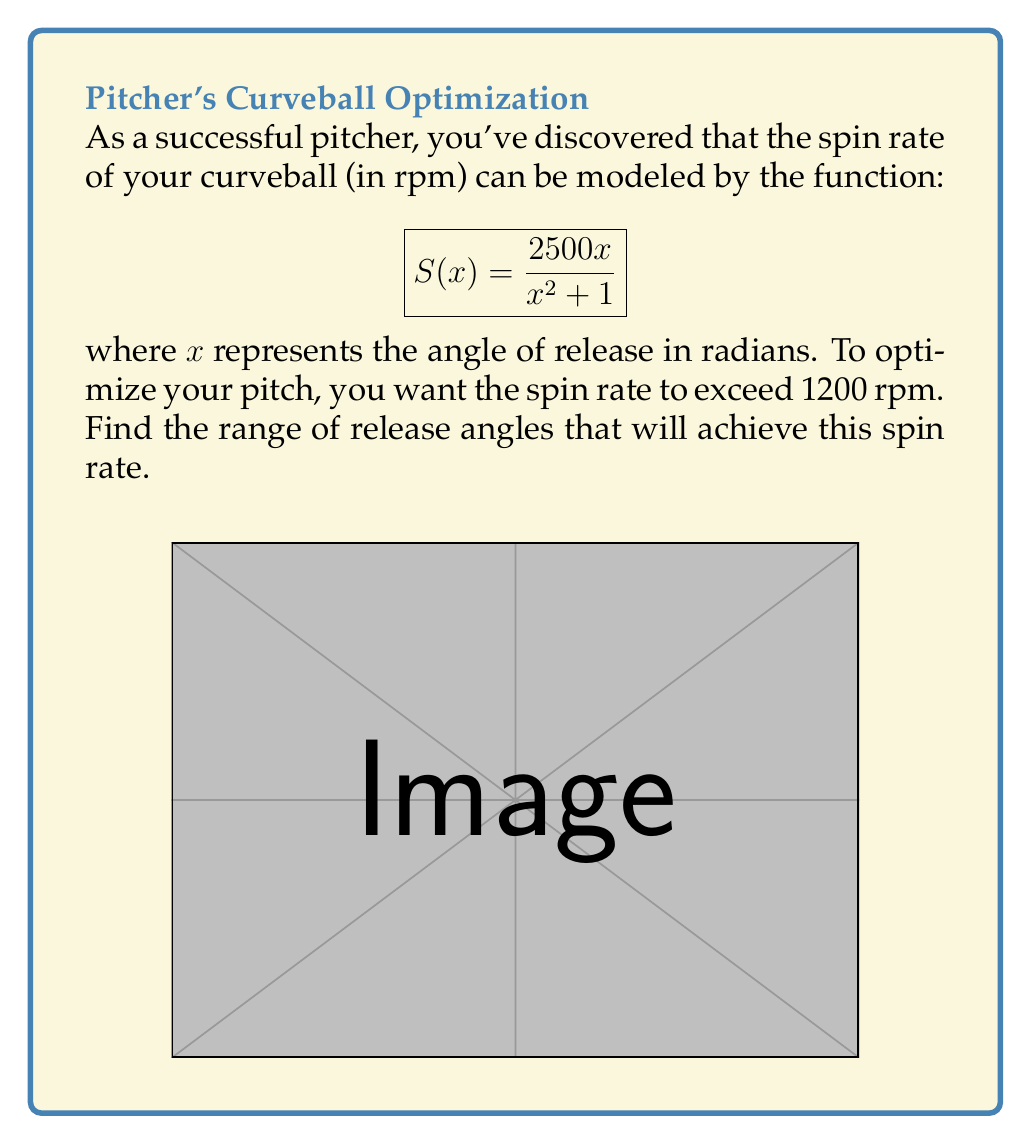Solve this math problem. Let's approach this step-by-step:

1) We want to find $x$ values where $S(x) > 1200$. This gives us the inequality:

   $$\frac{2500x}{x^2 + 1} > 1200$$

2) Multiply both sides by $(x^2 + 1)$ (which is always positive):

   $$2500x > 1200(x^2 + 1)$$

3) Expand the right side:

   $$2500x > 1200x^2 + 1200$$

4) Subtract 2500x from both sides:

   $$0 > 1200x^2 - 2500x + 1200$$

5) Divide by 1200 (doesn't change the inequality direction as it's positive):

   $$0 > x^2 - \frac{25}{12}x + 1$$

6) This is a quadratic inequality. To solve it, we need to find the roots of the quadratic equation:

   $$x^2 - \frac{25}{12}x + 1 = 0$$

7) Using the quadratic formula, $x = \frac{-b \pm \sqrt{b^2 - 4ac}}{2a}$, we get:

   $$x = \frac{\frac{25}{12} \pm \sqrt{(\frac{25}{12})^2 - 4(1)(1)}}{2(1)}$$

8) Simplifying:

   $$x = \frac{25 \pm \sqrt{625 - 576}}{24} = \frac{25 \pm 7}{24}$$

9) So the roots are:

   $$x_1 = \frac{25 + 7}{24} = \frac{4}{3} \approx 1.33$$
   $$x_2 = \frac{25 - 7}{24} = \frac{3}{4} = 0.75$$

10) The parabola opens upward (positive leading coefficient), so the inequality is satisfied between these roots.

Therefore, the spin rate exceeds 1200 rpm when the release angle is between 0.75 and 1.33 radians.
Answer: $0.75 < x < 1.33$ radians 